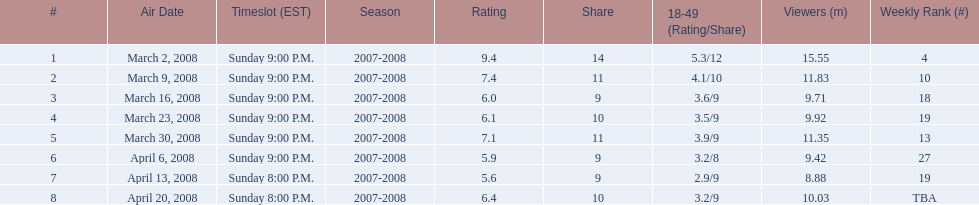Over how many days was the program broadcasted? 8. 